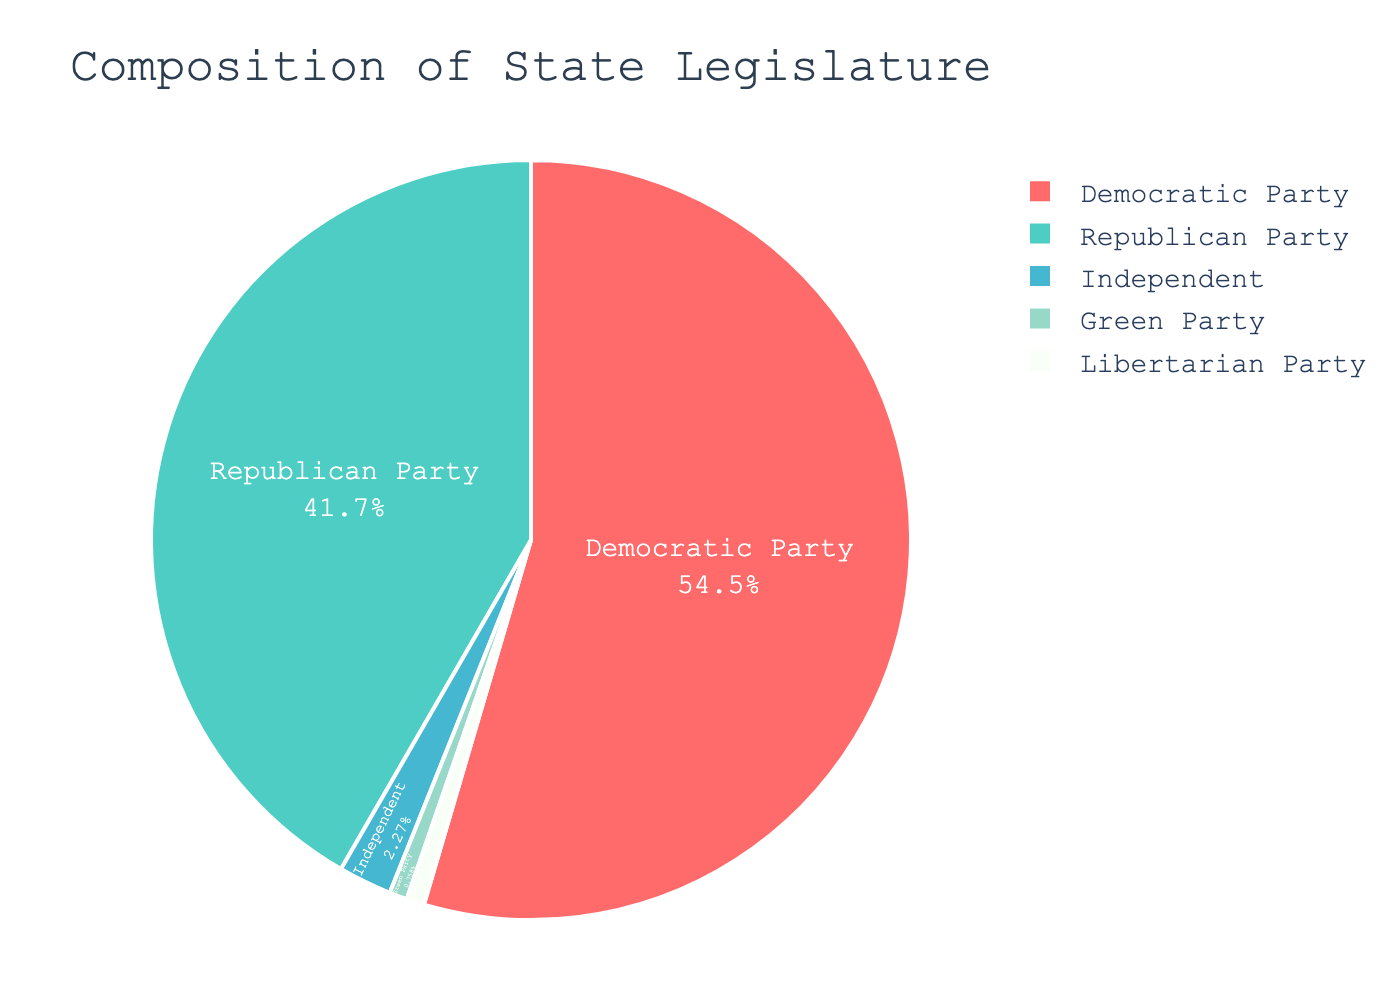What percentage of the seats are held by the Democratic Party? The pie chart displays the percentage of seats for each party. Look for the section labeled "Democratic Party" and note the percentage.
Answer: 55% Which party has the second largest number of seats? By examining the sizes of the pie segments, the Republican Party occupies the second largest section after the Democratic Party.
Answer: Republican Party What is the total number of seats held by the Green Party and Libertarian Party combined? Both the Green Party and Libertarian Party have 1 seat each. Summing these gives 1 + 1 = 2 seats.
Answer: 2 seats How many more seats does the Democratic Party have compared to the Republican Party? The Democratic Party has 72 seats, and the Republican Party has 55 seats. The difference is 72 - 55 = 17 seats.
Answer: 17 seats What fraction of the total seats is held by Independents? The Independent members hold 3 seats out of the total 132 seats. So the fraction is 3/132 which simplifies to 1/44.
Answer: 1/44 Which section of the pie chart is the smallest? By visual inspection, the Green Party and Libertarian Party segments are the smallest, both with 1 seat each.
Answer: Green Party and Libertarian Party Is the percentage of seats held by the Democratic Party greater than 50%? The figure shows the Democratic Party holding 55% of the seats, which is greater than 50%.
Answer: Yes What is the combined percentage of seats held by parties other than the Democratic Party? Subtract the percentage of seats held by the Democratic Party (55%) from 100%, giving 100% - 55% = 45%.
Answer: 45% Which party has the fewest seats, and how many seats do they have? Both the Green Party and Libertarian Party have the fewest seats, with each having 1 seat.
Answer: Green Party and Libertarian Party, 1 seat each What color represents the Republican Party on the pie chart? The colors in the pie chart distinguish different parties. The Republican Party is represented by the color green.
Answer: Green 